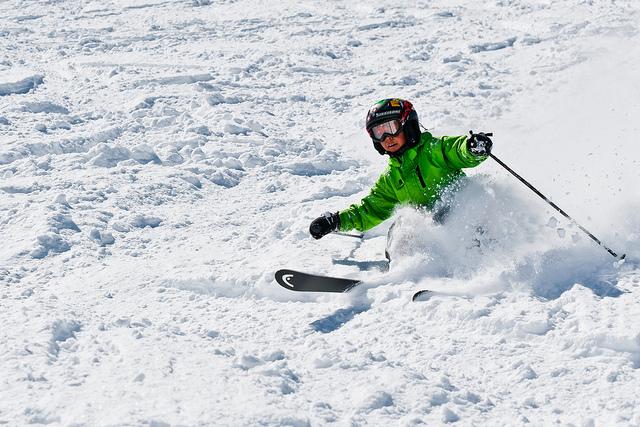Could this man get buried in the snow easily?
Keep it brief. Yes. How many ski poles are there?
Be succinct. 2. What color is the person's jacket?
Short answer required. Green. What activity is the man doing?
Give a very brief answer. Skiing. What color is the helmet?
Quick response, please. Black. Is the person wearing sunglasses?
Short answer required. Yes. 